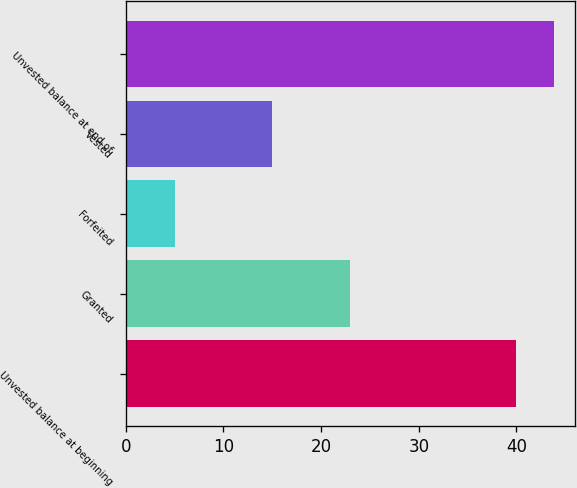<chart> <loc_0><loc_0><loc_500><loc_500><bar_chart><fcel>Unvested balance at beginning<fcel>Granted<fcel>Forfeited<fcel>Vested<fcel>Unvested balance at end of<nl><fcel>40<fcel>23<fcel>5<fcel>15<fcel>43.8<nl></chart> 